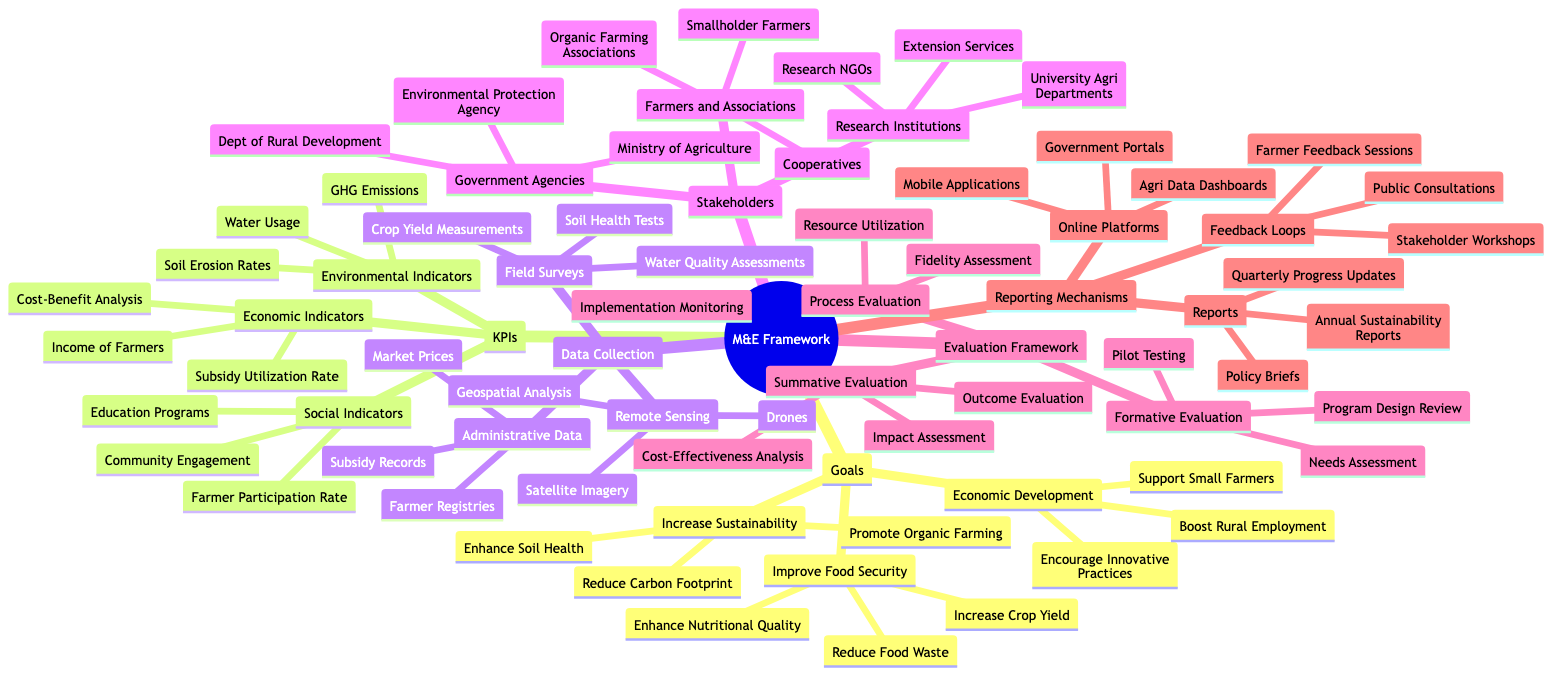What are the three main goals of the M&E Framework? The diagram specifies three main goals under the "Goals" category: Increase Sustainability, Improve Food Security, and Economic Development.
Answer: Increase Sustainability, Improve Food Security, Economic Development How many environmental indicators are listed in the KPIs? Under the "Key Performance Indicators" section, there are three environmental indicators: Water Usage, Soil Erosion Rates, and Greenhouse Gas Emissions. Therefore, the count is three.
Answer: Three Which stakeholder group includes smallholder farmers? In the "Stakeholders" section, the group "Farmers and Farmer Associations" specifically mentions smallholder farmers.
Answer: Farmers and Farmer Associations What type of evaluation falls under "Process Evaluation"? The "Evaluation Framework" category lists "Implementation Monitoring," "Fidelity Assessment," and "Resource Utilization" as components of Process Evaluation.
Answer: Implementation Monitoring, Fidelity Assessment, Resource Utilization What method is used for crop yield measurements? The "Data Collection Methods" section indicates that "Field Surveys" include "Crop Yield Measurements" as one of the techniques for data collection.
Answer: Field Surveys How many feedback loops are mentioned in the feedback and reporting mechanisms? The "Feedback and Reporting Mechanisms" outlines three types of feedback loops: Stakeholder Workshops, Farmer Feedback Sessions, and Public Consultations, which totals three.
Answer: Three What is one of the goals under the Economic Development category? The goals listed under "Economic Development" include "Support Small Farmers," "Encourage Innovative Practices," and "Boost Rural Employment." Therefore, one example could be "Support Small Farmers."
Answer: Support Small Farmers What type of reports are included in the reporting mechanisms? The section on "Reports" under "Feedback and Reporting Mechanisms" includes "Annual Sustainability Reports," "Quarterly Progress Updates," and "Policy Briefs," indicating there are multiple types of reports.
Answer: Annual Sustainability Reports, Quarterly Progress Updates, Policy Briefs 